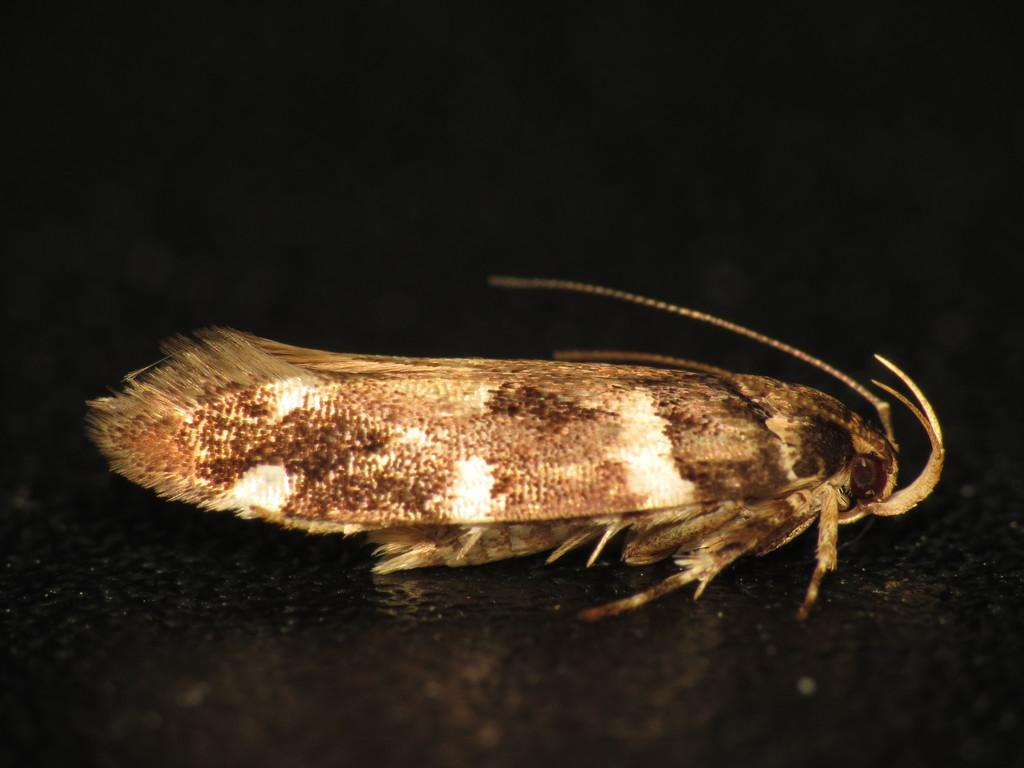What type of insect is in the picture? There is a moth in the picture. How does the moth blend in with its surroundings? The moth resembles tree bark, which helps it blend in with its surroundings. What is the color of the background in the image? The background of the image is dark. What time of day is depicted in the image? The provided facts do not mention the time of day, so it cannot be determined from the image. What type of tool is being used by the moth in the image? There is no tool, such as a wrench, present in the image. 